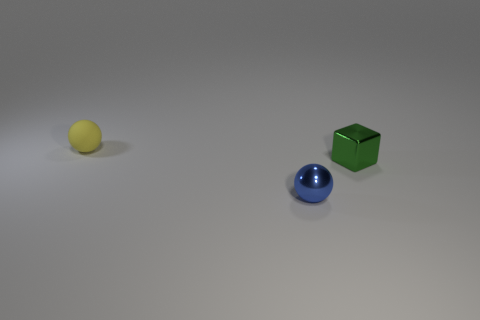Subtract all spheres. How many objects are left? 1 Subtract 1 cubes. How many cubes are left? 0 Add 1 tiny balls. How many tiny balls are left? 3 Add 1 cubes. How many cubes exist? 2 Add 3 tiny rubber balls. How many objects exist? 6 Subtract 0 yellow cubes. How many objects are left? 3 Subtract all brown cubes. Subtract all green balls. How many cubes are left? 1 Subtract all purple blocks. How many blue balls are left? 1 Subtract all tiny green rubber objects. Subtract all green shiny things. How many objects are left? 2 